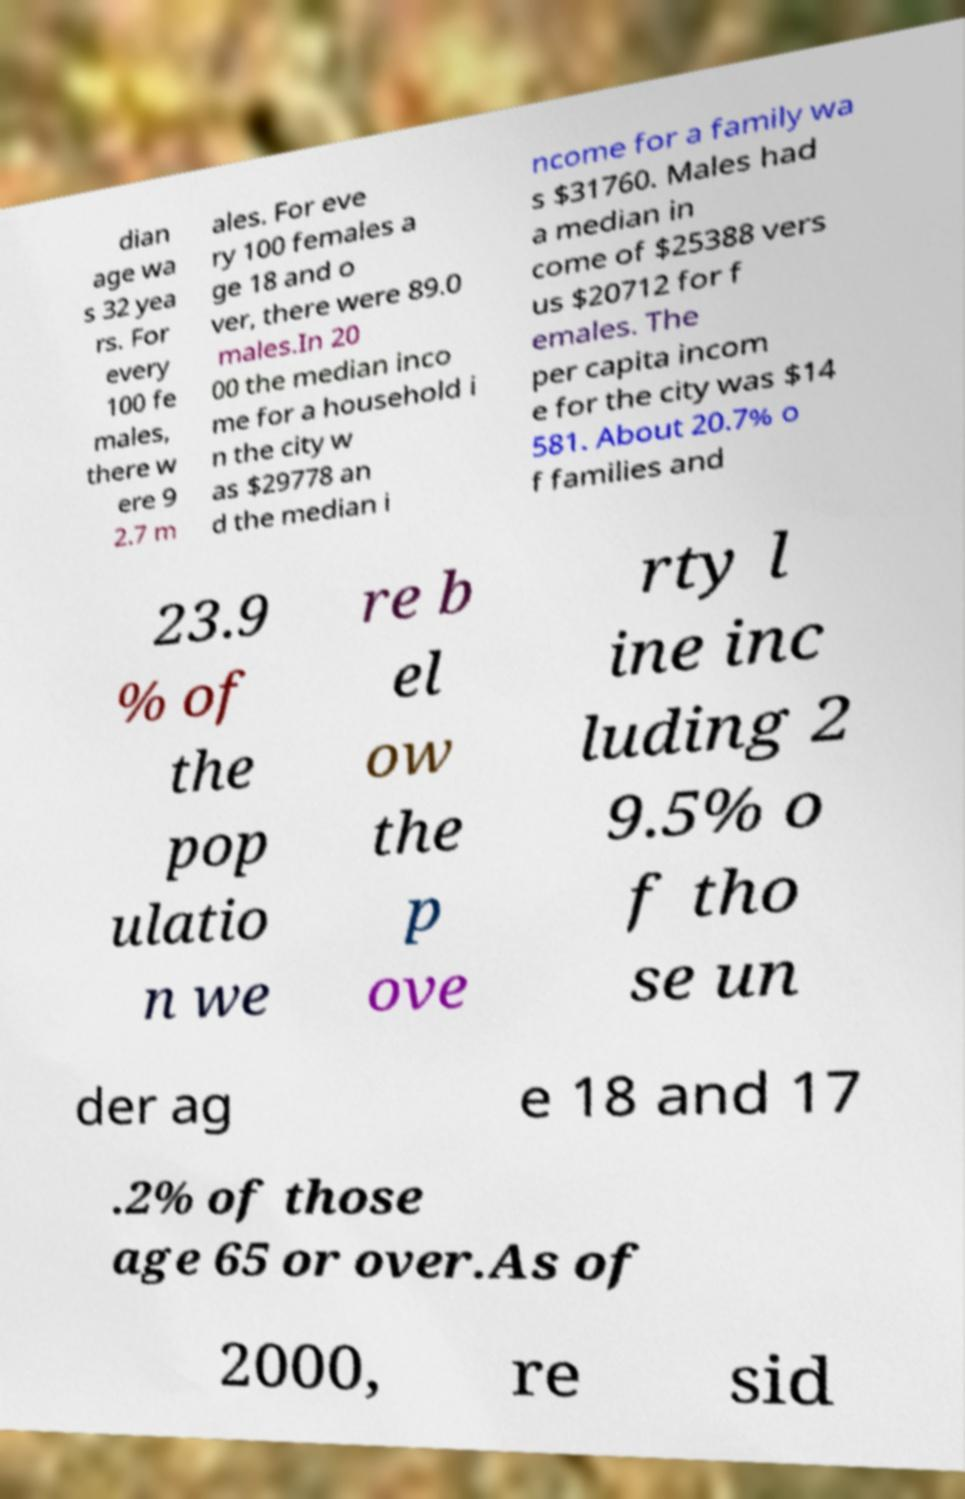Can you read and provide the text displayed in the image?This photo seems to have some interesting text. Can you extract and type it out for me? dian age wa s 32 yea rs. For every 100 fe males, there w ere 9 2.7 m ales. For eve ry 100 females a ge 18 and o ver, there were 89.0 males.In 20 00 the median inco me for a household i n the city w as $29778 an d the median i ncome for a family wa s $31760. Males had a median in come of $25388 vers us $20712 for f emales. The per capita incom e for the city was $14 581. About 20.7% o f families and 23.9 % of the pop ulatio n we re b el ow the p ove rty l ine inc luding 2 9.5% o f tho se un der ag e 18 and 17 .2% of those age 65 or over.As of 2000, re sid 